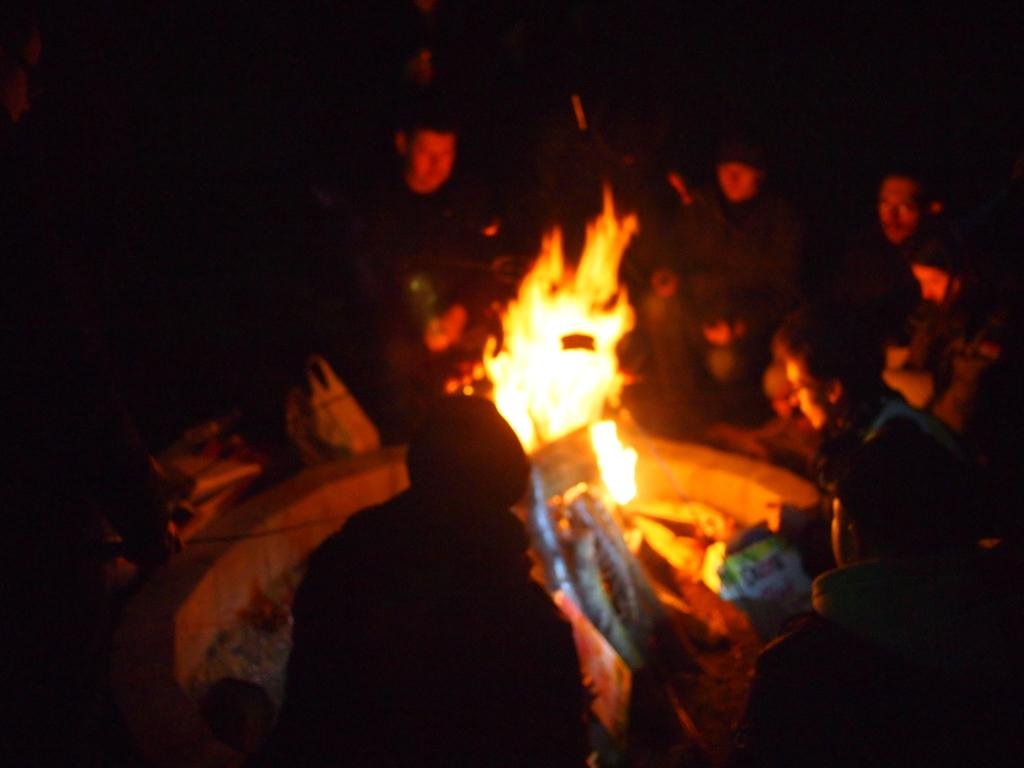What is happening in the image? There is a group of people in the image, and they are around a fire. What can be seen in the middle of the image? There are objects in the middle of the image. How would you describe the background of the image? The background of the image has a dark view. What type of grass is being used to start the fire in the image? There is no grass visible in the image, and the fire is already burning. Additionally, grass is not typically used to start a fire. 